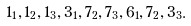<formula> <loc_0><loc_0><loc_500><loc_500>1 _ { 1 } , 1 _ { 2 } , 1 _ { 3 } , 3 _ { 1 } , 7 _ { 2 } , 7 _ { 3 } , 6 _ { 1 } , 7 _ { 2 } , 3 _ { 3 } .</formula> 